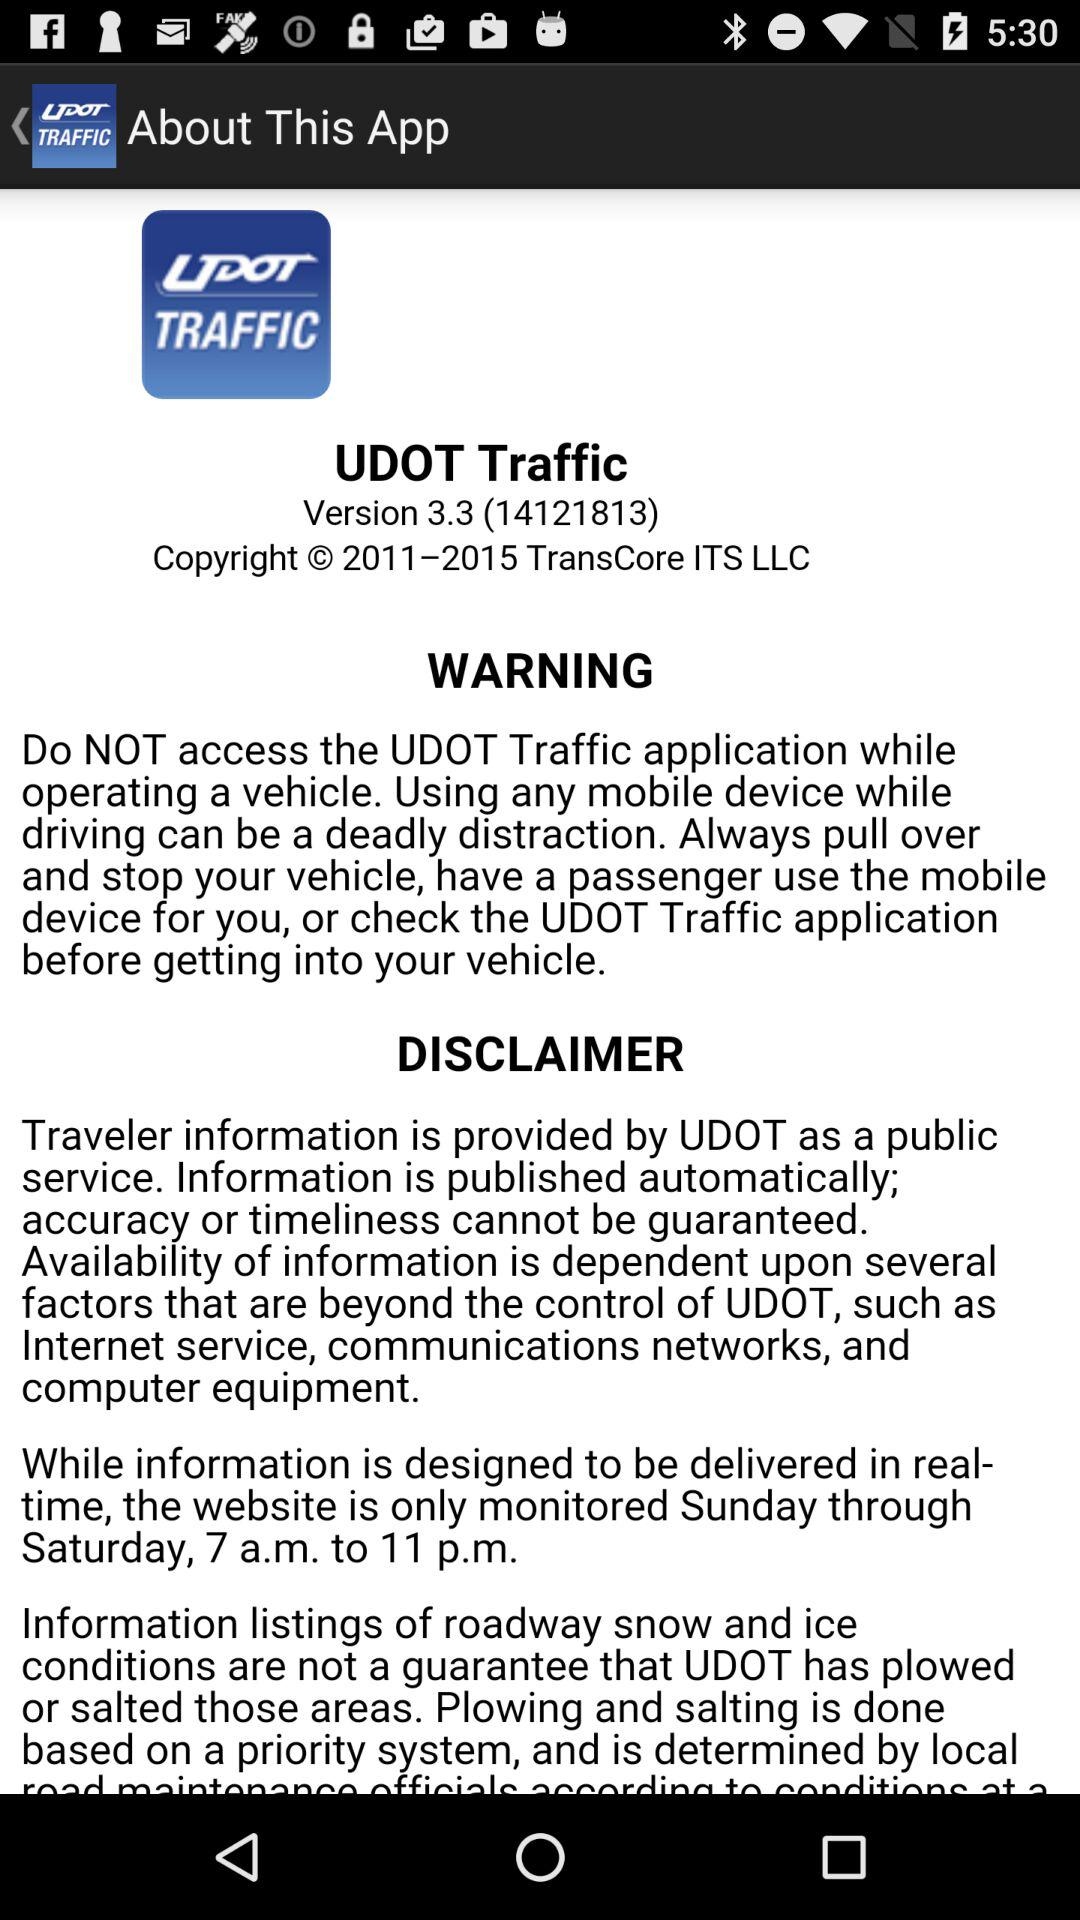What is the version? The version is 3.3 (14121813). 